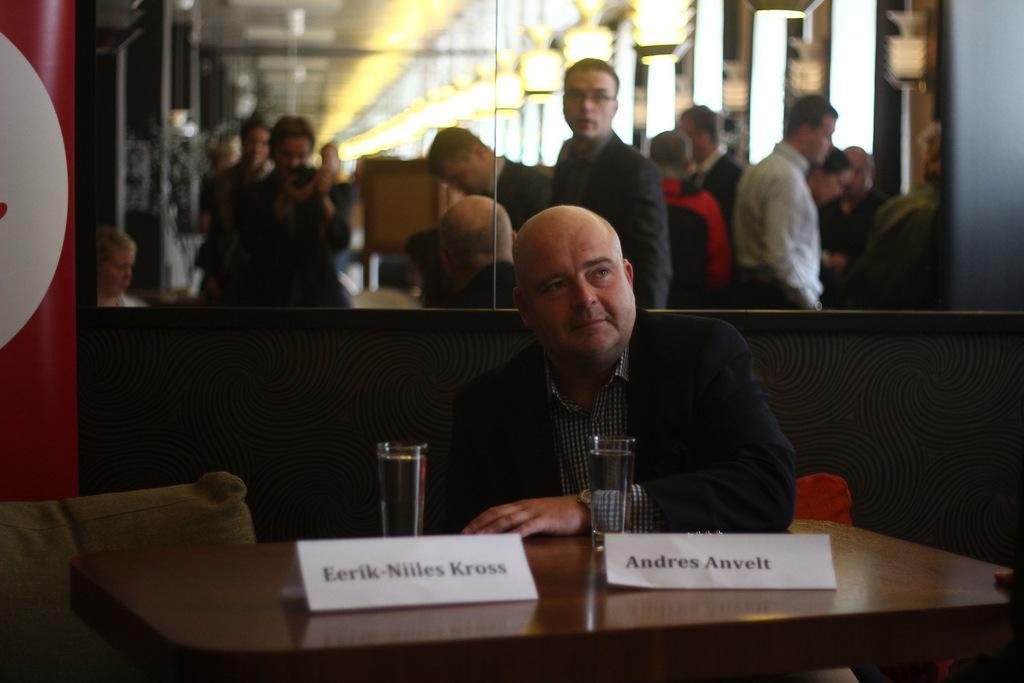Please provide a concise description of this image. In the picture it looks like a restaurant, there is a table and there are two name cards on the table there also two glasses filled with water in front of the table there is a man sitting he is wearing a blazer to the left side of the man there is a pillow,behind him there is a mirror inside the mirror there are few people,some of them are standing and some of them are sitting in the background there are some windows and lights and there is also a chair. 